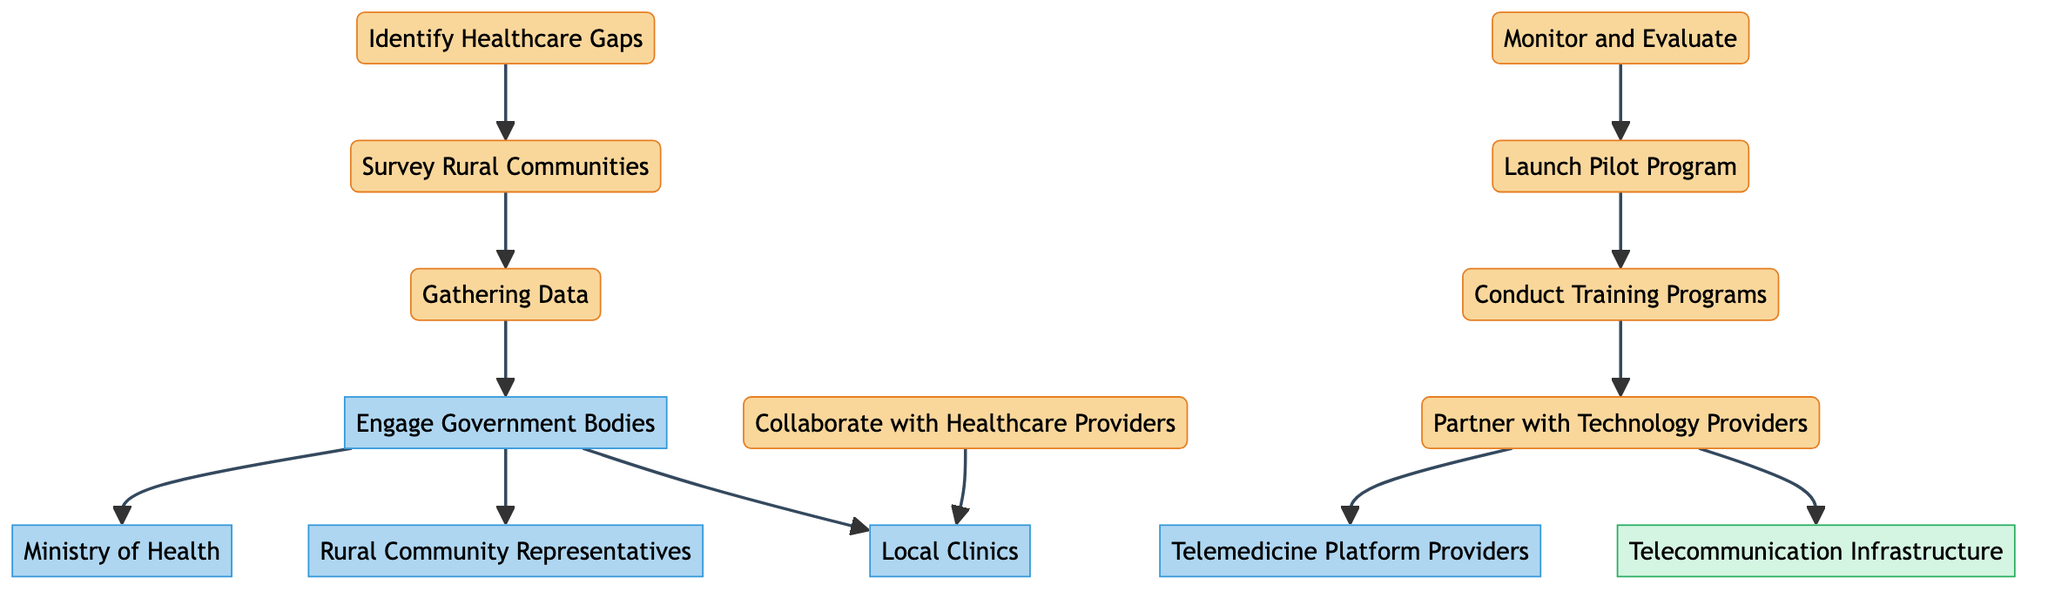What is the first task in establishing telemedicine services? The first task listed in the diagram is "Identify Healthcare Gaps," which is the starting point of the process.
Answer: Identify Healthcare Gaps How many stakeholders are involved in the process? The diagram shows a total of five stakeholders: Ministry of Health, Rural Community Representatives, Local Clinics, Telemedicine Platform Providers, and Government Bodies.
Answer: Five Which task directly follows "Survey Rural Communities"? The task directly following "Survey Rural Communities" is "Gathering Data," as indicated by the directed edge in the diagram connecting these two tasks.
Answer: Gathering Data Who do you engage after identifying healthcare gaps? After identifying healthcare gaps, the next step is to "Engage Government Bodies," which involves bringing relevant authorities into the process for further action.
Answer: Engage Government Bodies What resource is associated with partnering with technology providers? The resource associated with "Partner with Technology Providers" is "Telecommunication Infrastructure," which will be utilized to establish the necessary communication framework for telemedicine.
Answer: Telecommunication Infrastructure How many tasks are listed in the diagram? The diagram outlines a total of seven tasks that are part of establishing telemedicine services, from identifying healthcare gaps to monitoring and evaluating the pilot program.
Answer: Seven What is the final task in the outlined process? The final task of the process is "Monitor and Evaluate," occurring after the launch of the pilot program to assess its effectiveness and make necessary adjustments.
Answer: Monitor and Evaluate Which stakeholder collaborates with local clinics? "Collaborate with Healthcare Providers" is the task that links specifically to "Local Clinics," indicating the involvement of healthcare professionals in the telemedicine initiative.
Answer: Local Clinics What follows the "Launch Pilot Program"? Following the "Launch Pilot Program," the next step is "Monitor and Evaluate," which is crucial for understanding the pilot's success and areas for improvement.
Answer: Monitor and Evaluate 